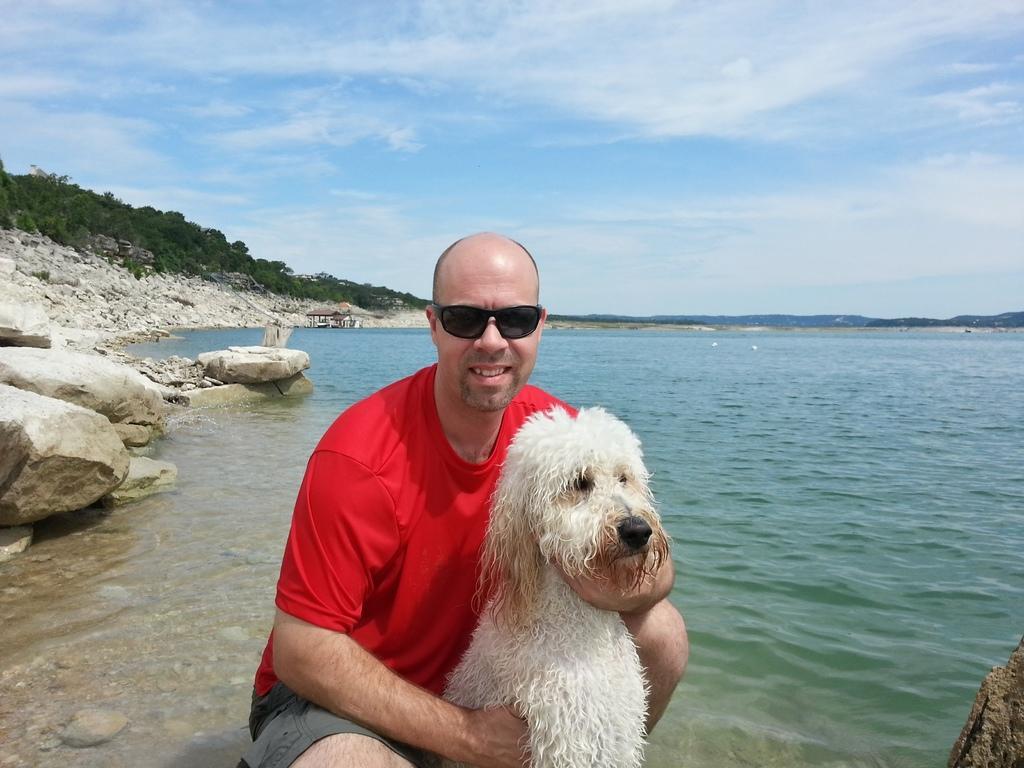How would you summarize this image in a sentence or two? In this image there is a person wearing a red top is holding a dog. He is wearing goggles. Left side there are rocks. Behind there are trees. Right side there is a lake. Behind there are hills. Top of the image there is sky with some clouds. 